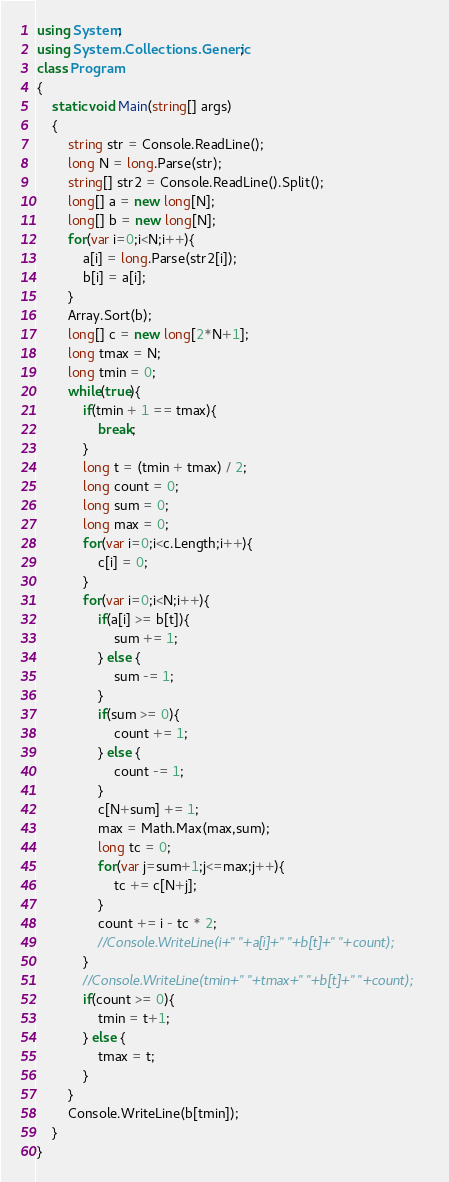<code> <loc_0><loc_0><loc_500><loc_500><_C#_>using System;
using System.Collections.Generic;
class Program
{
	static void Main(string[] args)
	{
		string str = Console.ReadLine();
		long N = long.Parse(str);
		string[] str2 = Console.ReadLine().Split();
		long[] a = new long[N];
		long[] b = new long[N];
		for(var i=0;i<N;i++){
			a[i] = long.Parse(str2[i]);
			b[i] = a[i];
		}
		Array.Sort(b);
		long[] c = new long[2*N+1];
		long tmax = N;
		long tmin = 0;
		while(true){
			if(tmin + 1 == tmax){
				break;
			}
			long t = (tmin + tmax) / 2;
			long count = 0;
			long sum = 0;
			long max = 0;
			for(var i=0;i<c.Length;i++){
				c[i] = 0;
			}
			for(var i=0;i<N;i++){
				if(a[i] >= b[t]){
					sum += 1;
				} else {
					sum -= 1;
				}
				if(sum >= 0){
					count += 1;
				} else {
					count -= 1;
				}
				c[N+sum] += 1;
				max = Math.Max(max,sum);
				long tc = 0;
				for(var j=sum+1;j<=max;j++){
					tc += c[N+j];
				}
				count += i - tc * 2;
				//Console.WriteLine(i+" "+a[i]+" "+b[t]+" "+count);
			}
			//Console.WriteLine(tmin+" "+tmax+" "+b[t]+" "+count);
			if(count >= 0){
				tmin = t+1;
			} else {
				tmax = t;
			}
		}
		Console.WriteLine(b[tmin]);
	}
}</code> 